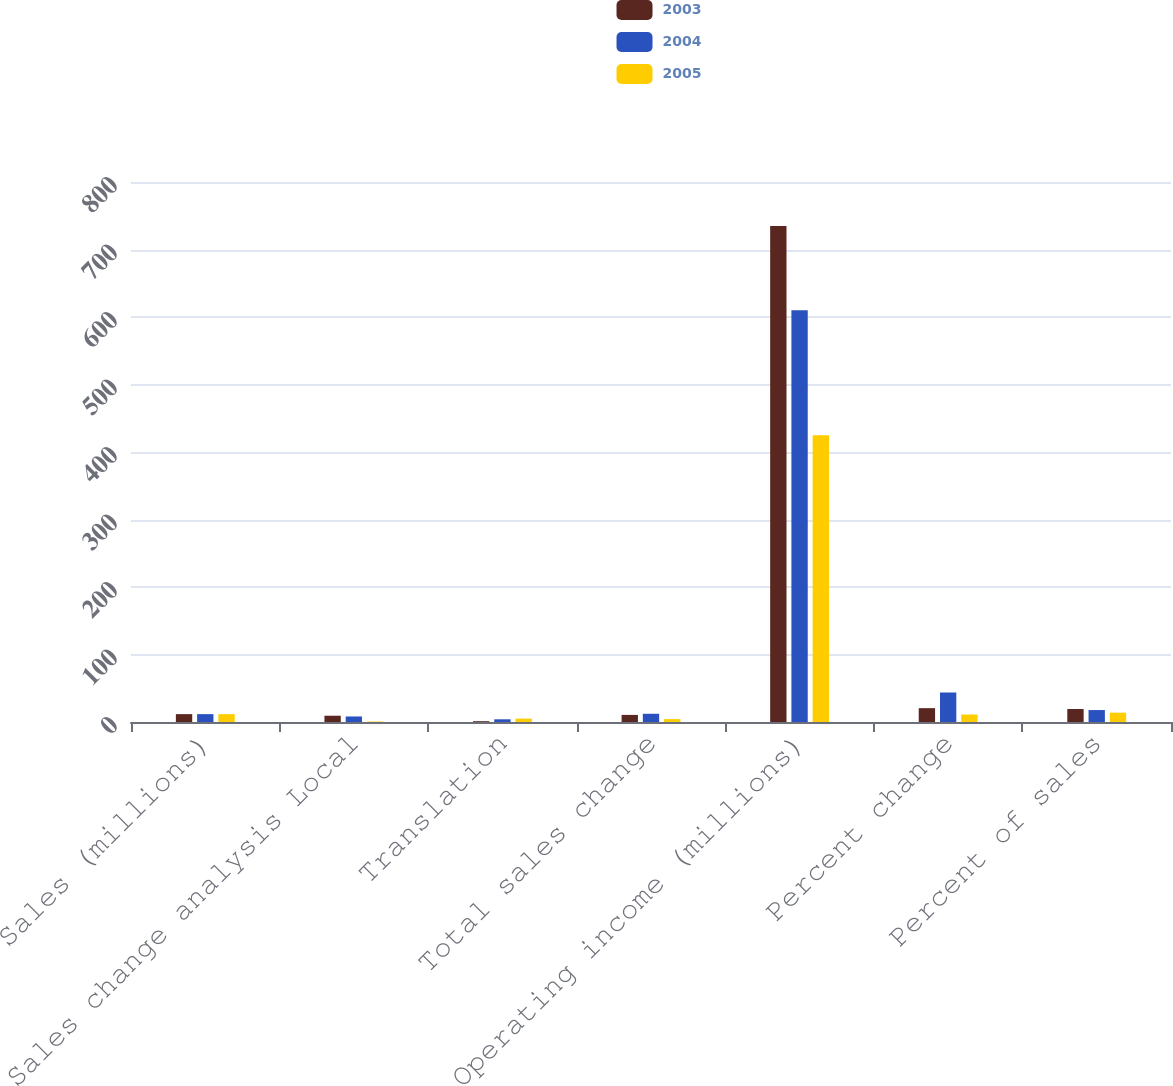<chart> <loc_0><loc_0><loc_500><loc_500><stacked_bar_chart><ecel><fcel>Sales (millions)<fcel>Sales change analysis Local<fcel>Translation<fcel>Total sales change<fcel>Operating income (millions)<fcel>Percent change<fcel>Percent of sales<nl><fcel>2003<fcel>11.65<fcel>9.3<fcel>1.2<fcel>10.5<fcel>735<fcel>20.5<fcel>19.3<nl><fcel>2004<fcel>11.65<fcel>8.2<fcel>4<fcel>12.2<fcel>610<fcel>43.7<fcel>17.7<nl><fcel>2005<fcel>11.65<fcel>0.7<fcel>5<fcel>4.3<fcel>425<fcel>11.1<fcel>13.8<nl></chart> 